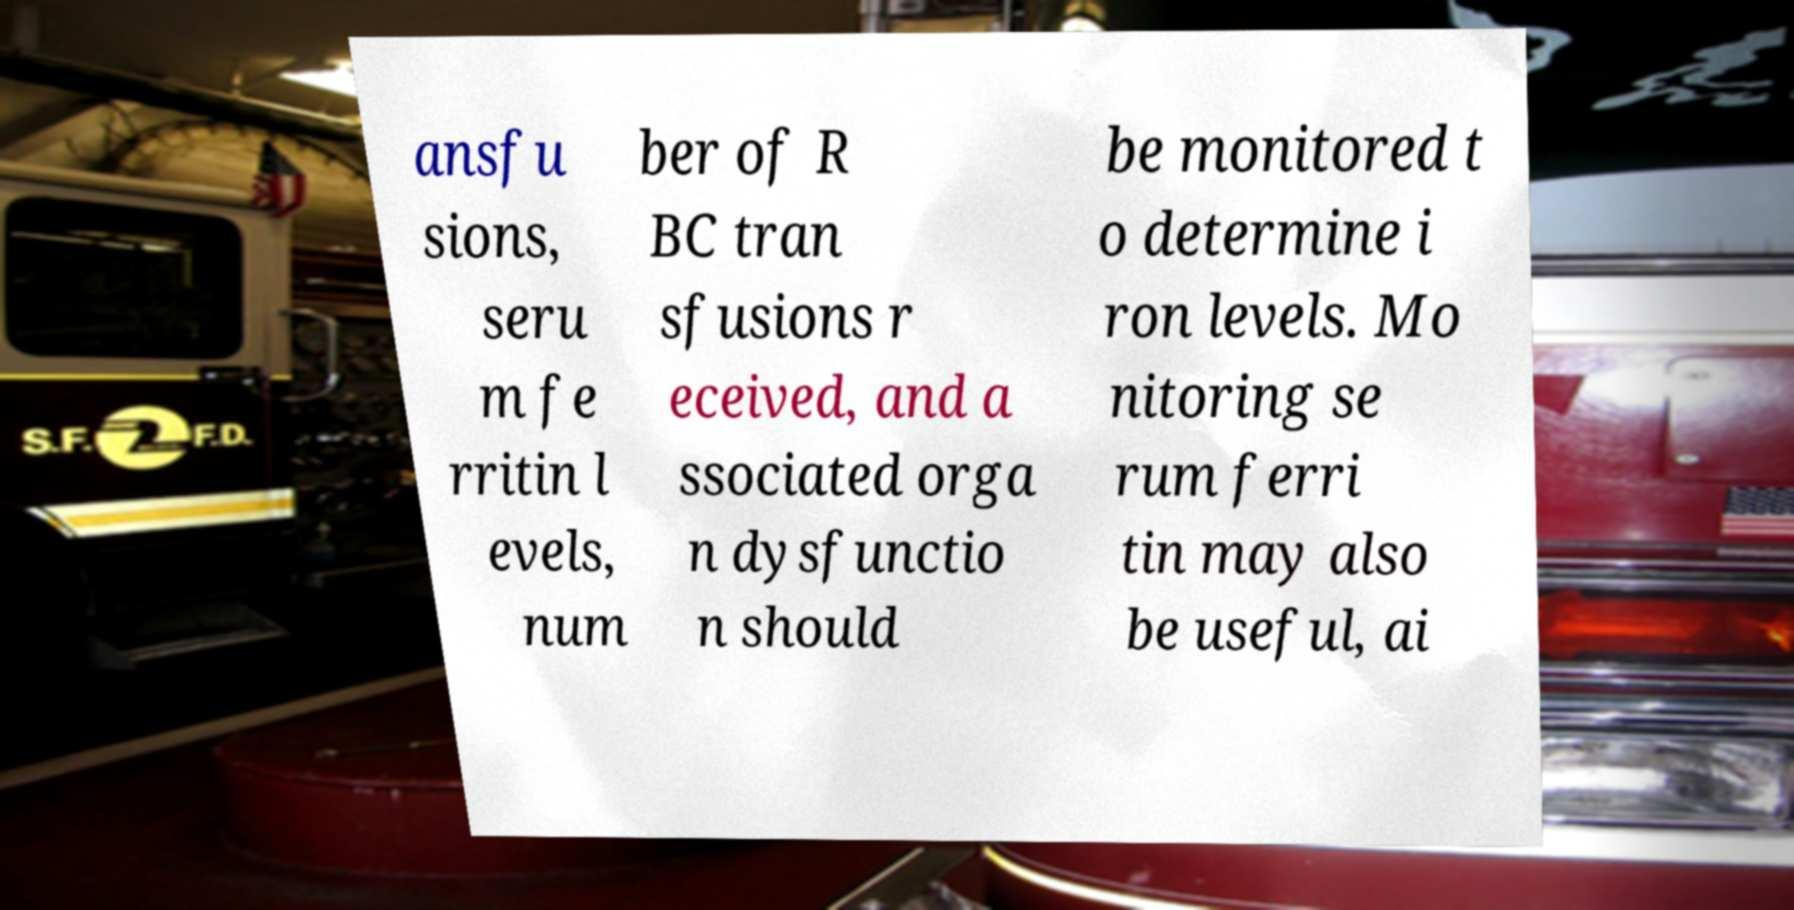Please read and relay the text visible in this image. What does it say? ansfu sions, seru m fe rritin l evels, num ber of R BC tran sfusions r eceived, and a ssociated orga n dysfunctio n should be monitored t o determine i ron levels. Mo nitoring se rum ferri tin may also be useful, ai 